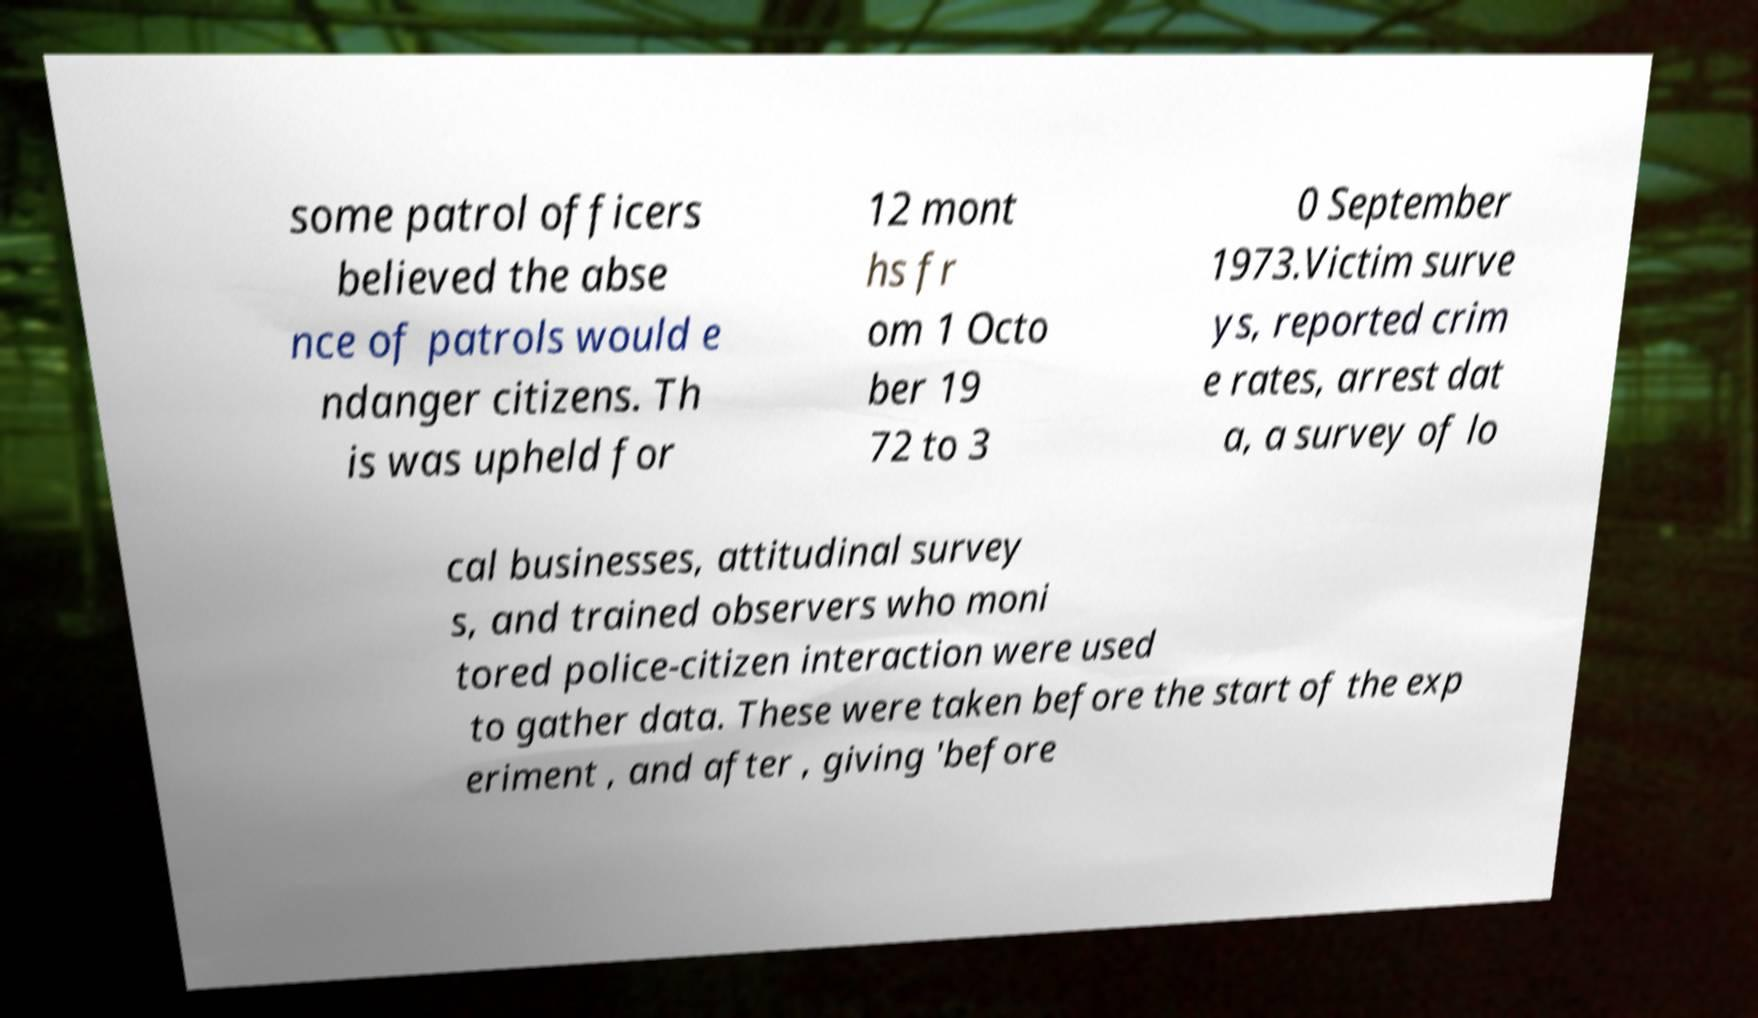What messages or text are displayed in this image? I need them in a readable, typed format. some patrol officers believed the abse nce of patrols would e ndanger citizens. Th is was upheld for 12 mont hs fr om 1 Octo ber 19 72 to 3 0 September 1973.Victim surve ys, reported crim e rates, arrest dat a, a survey of lo cal businesses, attitudinal survey s, and trained observers who moni tored police-citizen interaction were used to gather data. These were taken before the start of the exp eriment , and after , giving 'before 